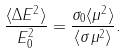<formula> <loc_0><loc_0><loc_500><loc_500>\frac { \langle \Delta E ^ { 2 } \rangle } { E _ { 0 } ^ { 2 } } = \frac { \sigma _ { 0 } \langle \mu ^ { 2 } \rangle } { \langle \sigma \mu ^ { 2 } \rangle } .</formula> 